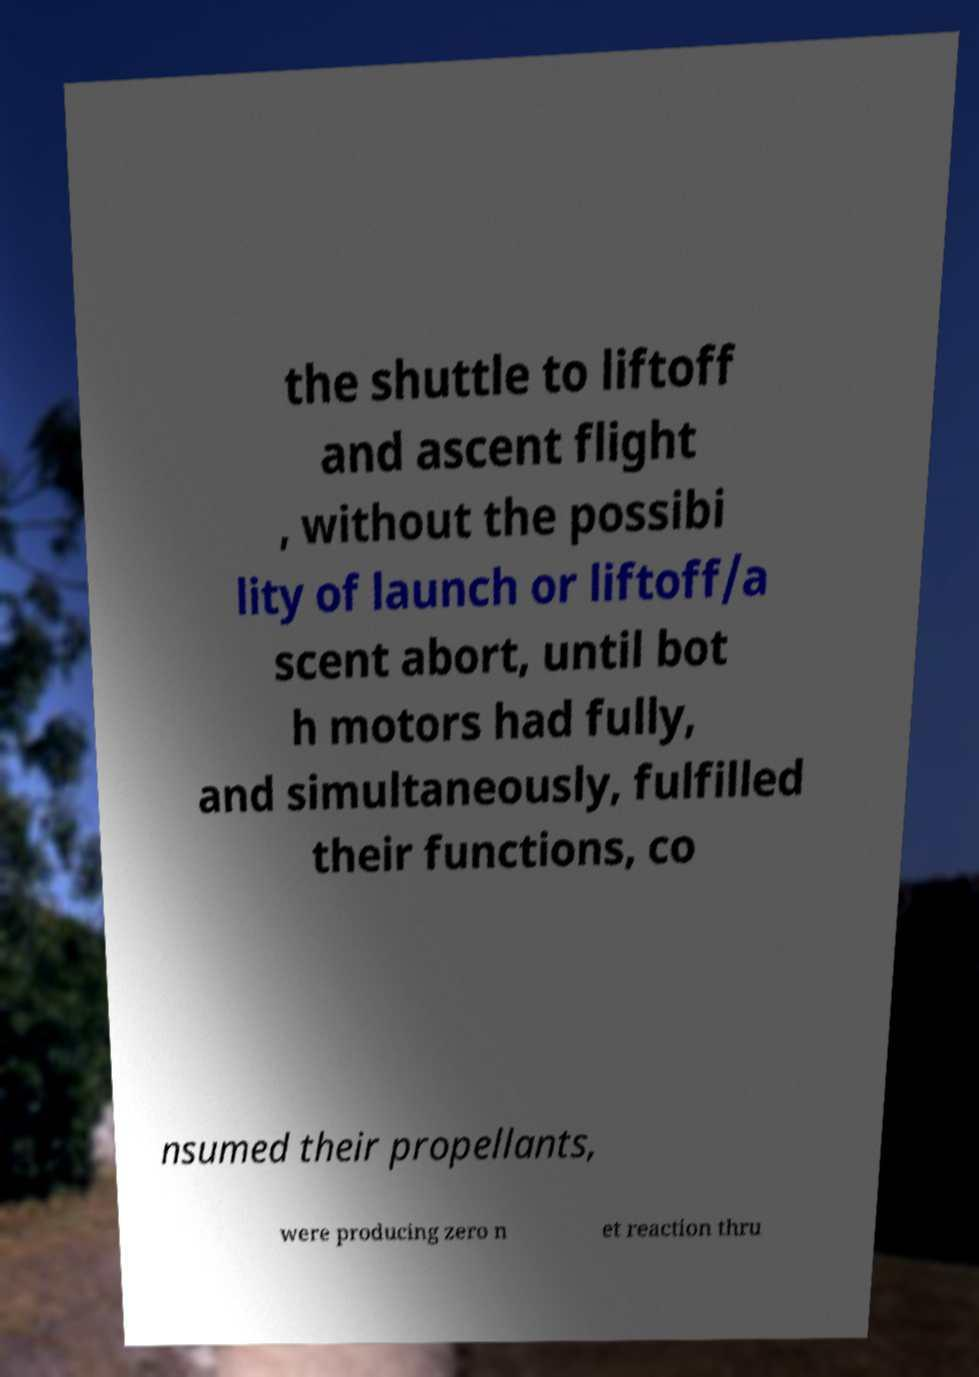Can you read and provide the text displayed in the image?This photo seems to have some interesting text. Can you extract and type it out for me? the shuttle to liftoff and ascent flight , without the possibi lity of launch or liftoff/a scent abort, until bot h motors had fully, and simultaneously, fulfilled their functions, co nsumed their propellants, were producing zero n et reaction thru 